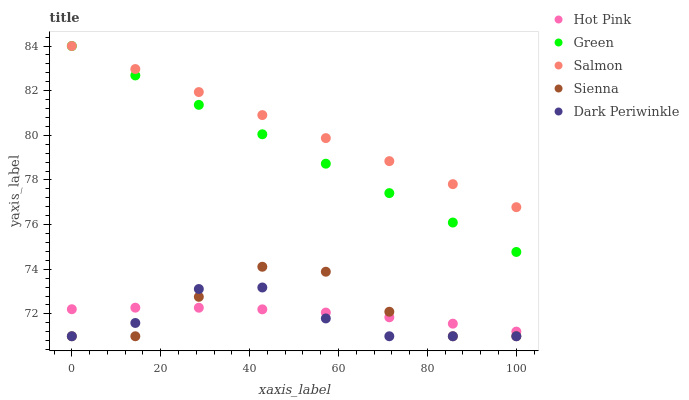Does Dark Periwinkle have the minimum area under the curve?
Answer yes or no. Yes. Does Salmon have the maximum area under the curve?
Answer yes or no. Yes. Does Hot Pink have the minimum area under the curve?
Answer yes or no. No. Does Hot Pink have the maximum area under the curve?
Answer yes or no. No. Is Green the smoothest?
Answer yes or no. Yes. Is Sienna the roughest?
Answer yes or no. Yes. Is Salmon the smoothest?
Answer yes or no. No. Is Salmon the roughest?
Answer yes or no. No. Does Sienna have the lowest value?
Answer yes or no. Yes. Does Hot Pink have the lowest value?
Answer yes or no. No. Does Green have the highest value?
Answer yes or no. Yes. Does Hot Pink have the highest value?
Answer yes or no. No. Is Hot Pink less than Salmon?
Answer yes or no. Yes. Is Green greater than Dark Periwinkle?
Answer yes or no. Yes. Does Sienna intersect Hot Pink?
Answer yes or no. Yes. Is Sienna less than Hot Pink?
Answer yes or no. No. Is Sienna greater than Hot Pink?
Answer yes or no. No. Does Hot Pink intersect Salmon?
Answer yes or no. No. 